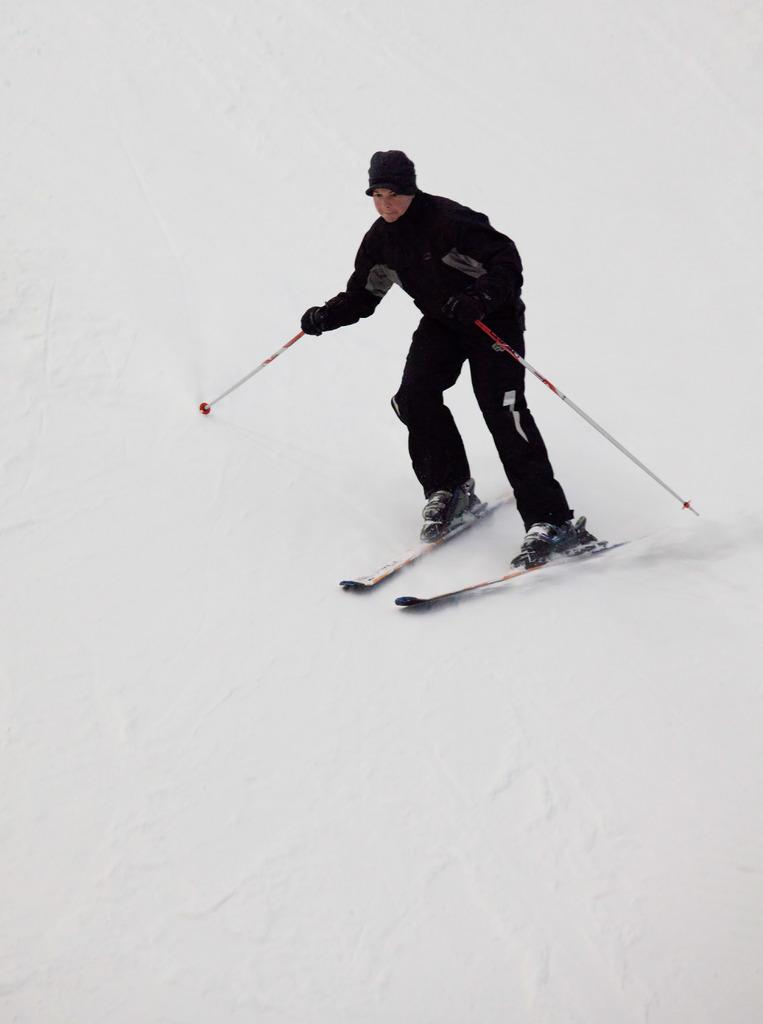What is the main subject of the image? There is a person in the image. What is the person wearing on their head? The person is wearing a cap. What is the person wearing on their hands? The person is wearing gloves. What is the person holding in their hands? The person is holding sticks. What is the person standing on? The person is standing on skis. What type of terrain is the person skiing on? The person is skiing on snow. What type of journey is the person's grandfather taking with the cats in the image? There is no mention of a journey, the person's grandfather, or cats in the image. 